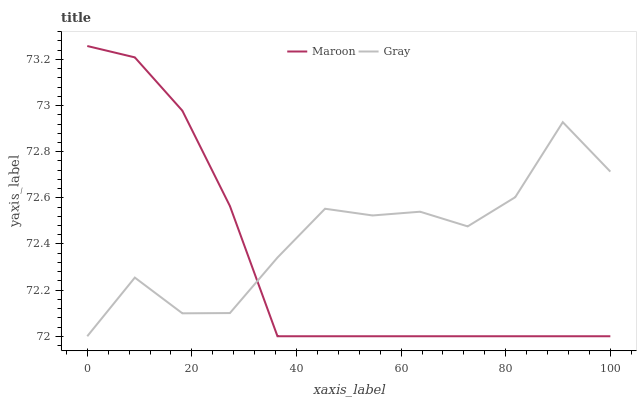Does Maroon have the minimum area under the curve?
Answer yes or no. Yes. Does Gray have the maximum area under the curve?
Answer yes or no. Yes. Does Maroon have the maximum area under the curve?
Answer yes or no. No. Is Maroon the smoothest?
Answer yes or no. Yes. Is Gray the roughest?
Answer yes or no. Yes. Is Maroon the roughest?
Answer yes or no. No. Does Gray have the lowest value?
Answer yes or no. Yes. Does Maroon have the highest value?
Answer yes or no. Yes. Does Gray intersect Maroon?
Answer yes or no. Yes. Is Gray less than Maroon?
Answer yes or no. No. Is Gray greater than Maroon?
Answer yes or no. No. 